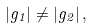<formula> <loc_0><loc_0><loc_500><loc_500>| g _ { 1 } | \neq | g _ { 2 } | \, ,</formula> 